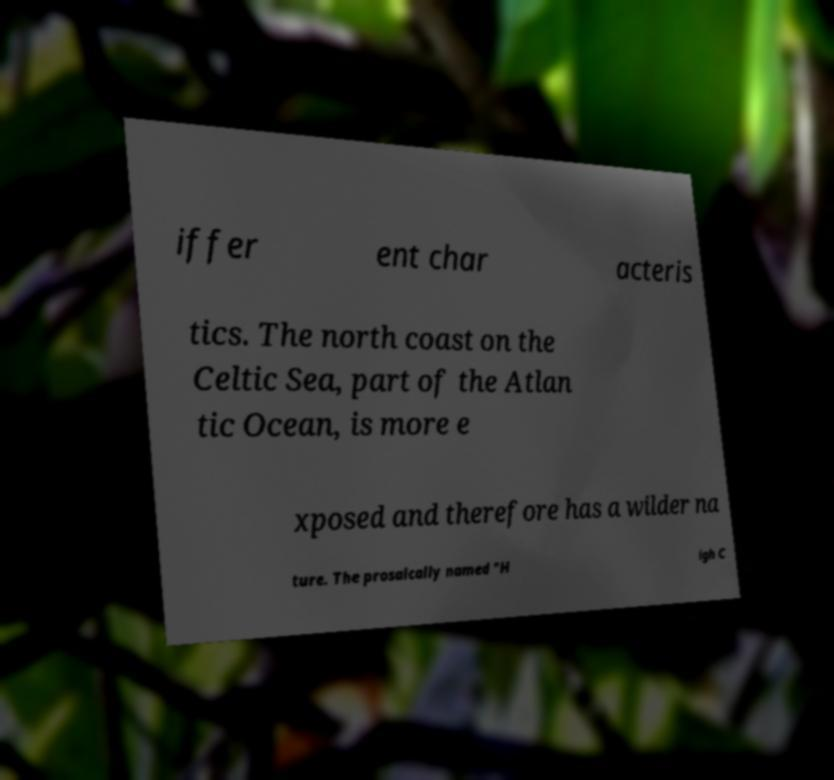Could you extract and type out the text from this image? iffer ent char acteris tics. The north coast on the Celtic Sea, part of the Atlan tic Ocean, is more e xposed and therefore has a wilder na ture. The prosaically named "H igh C 